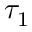Convert formula to latex. <formula><loc_0><loc_0><loc_500><loc_500>\tau _ { 1 }</formula> 